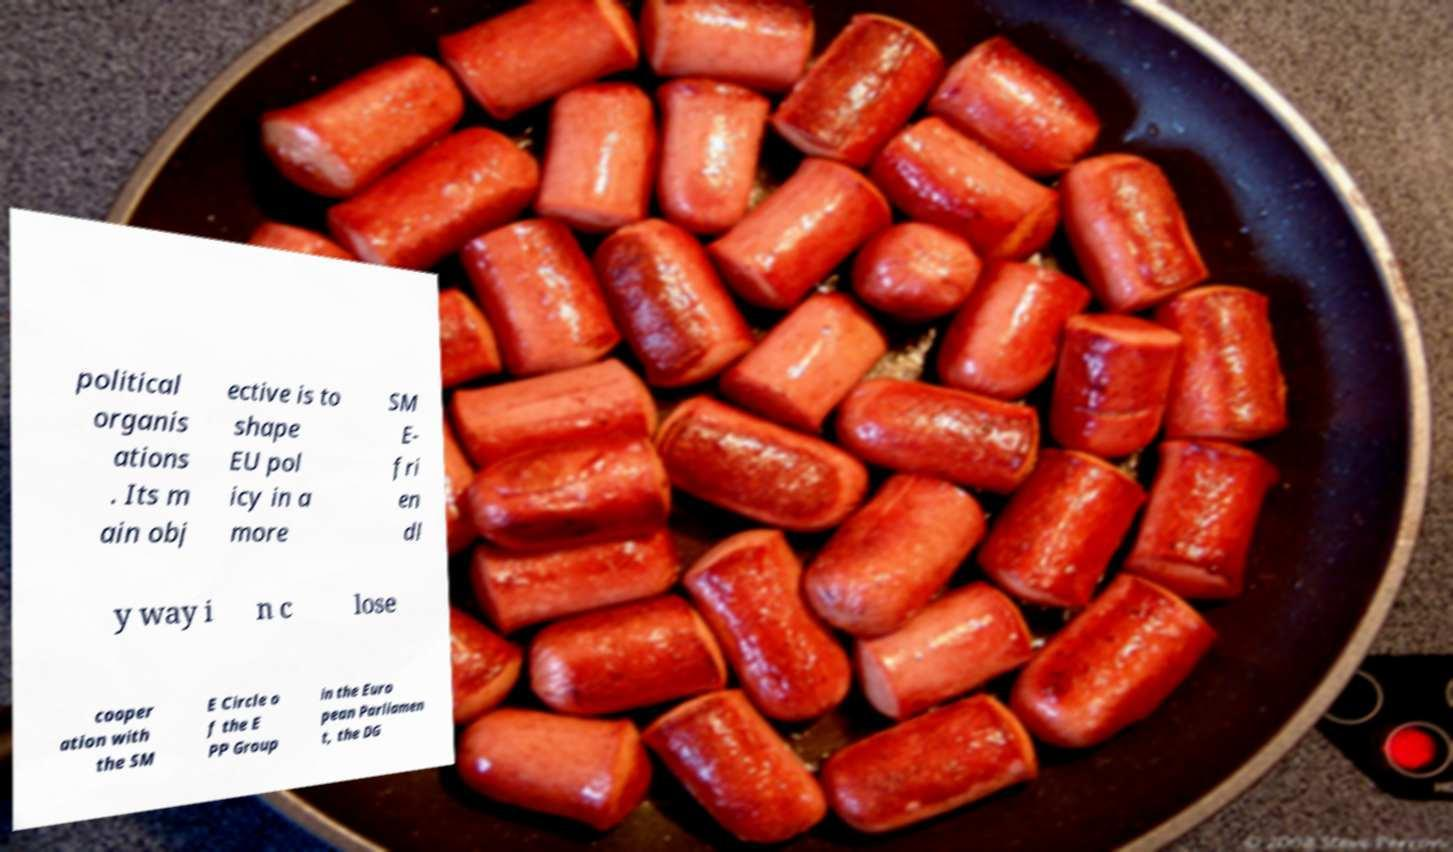Could you assist in decoding the text presented in this image and type it out clearly? political organis ations . Its m ain obj ective is to shape EU pol icy in a more SM E- fri en dl y way i n c lose cooper ation with the SM E Circle o f the E PP Group in the Euro pean Parliamen t, the DG 